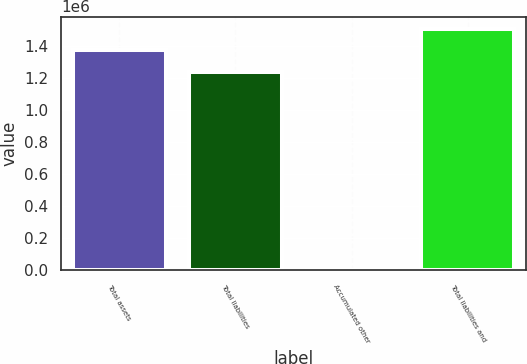<chart> <loc_0><loc_0><loc_500><loc_500><bar_chart><fcel>Total assets<fcel>Total liabilities<fcel>Accumulated other<fcel>Total liabilities and<nl><fcel>1.37073e+06<fcel>1.23573e+06<fcel>1557<fcel>1.50572e+06<nl></chart> 